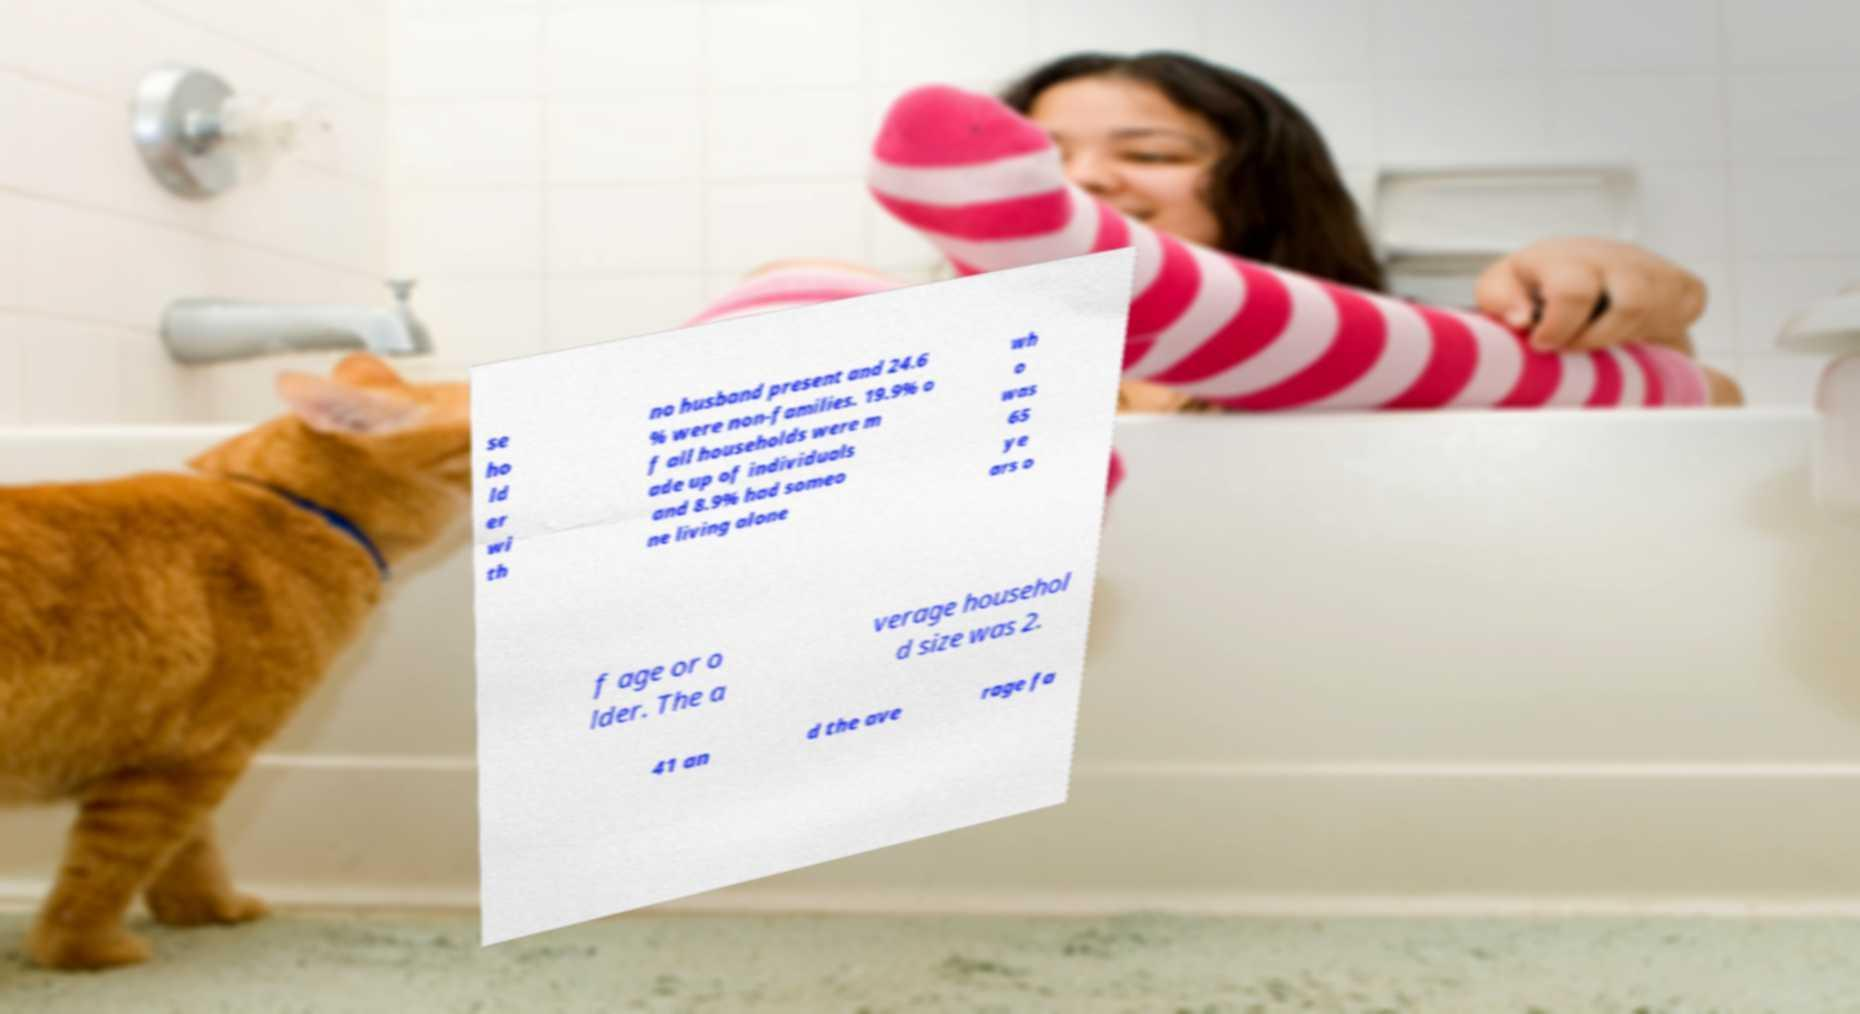Could you extract and type out the text from this image? se ho ld er wi th no husband present and 24.6 % were non-families. 19.9% o f all households were m ade up of individuals and 8.9% had someo ne living alone wh o was 65 ye ars o f age or o lder. The a verage househol d size was 2. 41 an d the ave rage fa 